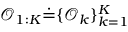<formula> <loc_0><loc_0><loc_500><loc_500>\mathcal { O } _ { 1 \colon K } \dot { = } \{ \mathcal { O } _ { k } \} _ { k = 1 } ^ { K }</formula> 